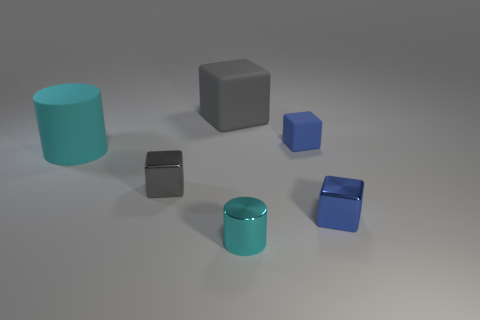What time of day does the lighting suggest? The lighting in the image appears neutral, suggesting it is artificial and not dependent on the time of day. It could be indoor lighting. 